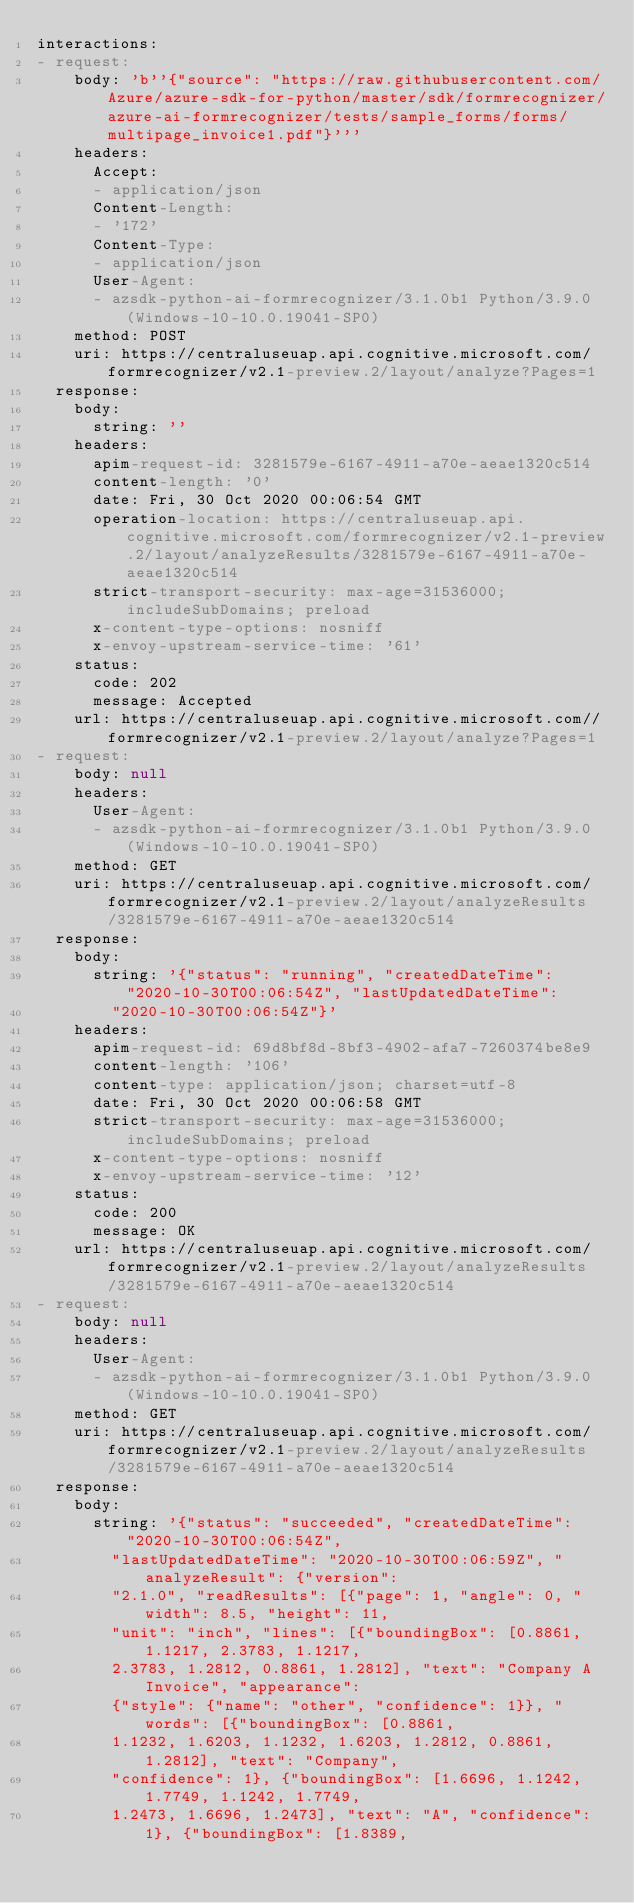Convert code to text. <code><loc_0><loc_0><loc_500><loc_500><_YAML_>interactions:
- request:
    body: 'b''{"source": "https://raw.githubusercontent.com/Azure/azure-sdk-for-python/master/sdk/formrecognizer/azure-ai-formrecognizer/tests/sample_forms/forms/multipage_invoice1.pdf"}'''
    headers:
      Accept:
      - application/json
      Content-Length:
      - '172'
      Content-Type:
      - application/json
      User-Agent:
      - azsdk-python-ai-formrecognizer/3.1.0b1 Python/3.9.0 (Windows-10-10.0.19041-SP0)
    method: POST
    uri: https://centraluseuap.api.cognitive.microsoft.com/formrecognizer/v2.1-preview.2/layout/analyze?Pages=1
  response:
    body:
      string: ''
    headers:
      apim-request-id: 3281579e-6167-4911-a70e-aeae1320c514
      content-length: '0'
      date: Fri, 30 Oct 2020 00:06:54 GMT
      operation-location: https://centraluseuap.api.cognitive.microsoft.com/formrecognizer/v2.1-preview.2/layout/analyzeResults/3281579e-6167-4911-a70e-aeae1320c514
      strict-transport-security: max-age=31536000; includeSubDomains; preload
      x-content-type-options: nosniff
      x-envoy-upstream-service-time: '61'
    status:
      code: 202
      message: Accepted
    url: https://centraluseuap.api.cognitive.microsoft.com//formrecognizer/v2.1-preview.2/layout/analyze?Pages=1
- request:
    body: null
    headers:
      User-Agent:
      - azsdk-python-ai-formrecognizer/3.1.0b1 Python/3.9.0 (Windows-10-10.0.19041-SP0)
    method: GET
    uri: https://centraluseuap.api.cognitive.microsoft.com/formrecognizer/v2.1-preview.2/layout/analyzeResults/3281579e-6167-4911-a70e-aeae1320c514
  response:
    body:
      string: '{"status": "running", "createdDateTime": "2020-10-30T00:06:54Z", "lastUpdatedDateTime":
        "2020-10-30T00:06:54Z"}'
    headers:
      apim-request-id: 69d8bf8d-8bf3-4902-afa7-7260374be8e9
      content-length: '106'
      content-type: application/json; charset=utf-8
      date: Fri, 30 Oct 2020 00:06:58 GMT
      strict-transport-security: max-age=31536000; includeSubDomains; preload
      x-content-type-options: nosniff
      x-envoy-upstream-service-time: '12'
    status:
      code: 200
      message: OK
    url: https://centraluseuap.api.cognitive.microsoft.com/formrecognizer/v2.1-preview.2/layout/analyzeResults/3281579e-6167-4911-a70e-aeae1320c514
- request:
    body: null
    headers:
      User-Agent:
      - azsdk-python-ai-formrecognizer/3.1.0b1 Python/3.9.0 (Windows-10-10.0.19041-SP0)
    method: GET
    uri: https://centraluseuap.api.cognitive.microsoft.com/formrecognizer/v2.1-preview.2/layout/analyzeResults/3281579e-6167-4911-a70e-aeae1320c514
  response:
    body:
      string: '{"status": "succeeded", "createdDateTime": "2020-10-30T00:06:54Z",
        "lastUpdatedDateTime": "2020-10-30T00:06:59Z", "analyzeResult": {"version":
        "2.1.0", "readResults": [{"page": 1, "angle": 0, "width": 8.5, "height": 11,
        "unit": "inch", "lines": [{"boundingBox": [0.8861, 1.1217, 2.3783, 1.1217,
        2.3783, 1.2812, 0.8861, 1.2812], "text": "Company A Invoice", "appearance":
        {"style": {"name": "other", "confidence": 1}}, "words": [{"boundingBox": [0.8861,
        1.1232, 1.6203, 1.1232, 1.6203, 1.2812, 0.8861, 1.2812], "text": "Company",
        "confidence": 1}, {"boundingBox": [1.6696, 1.1242, 1.7749, 1.1242, 1.7749,
        1.2473, 1.6696, 1.2473], "text": "A", "confidence": 1}, {"boundingBox": [1.8389,</code> 